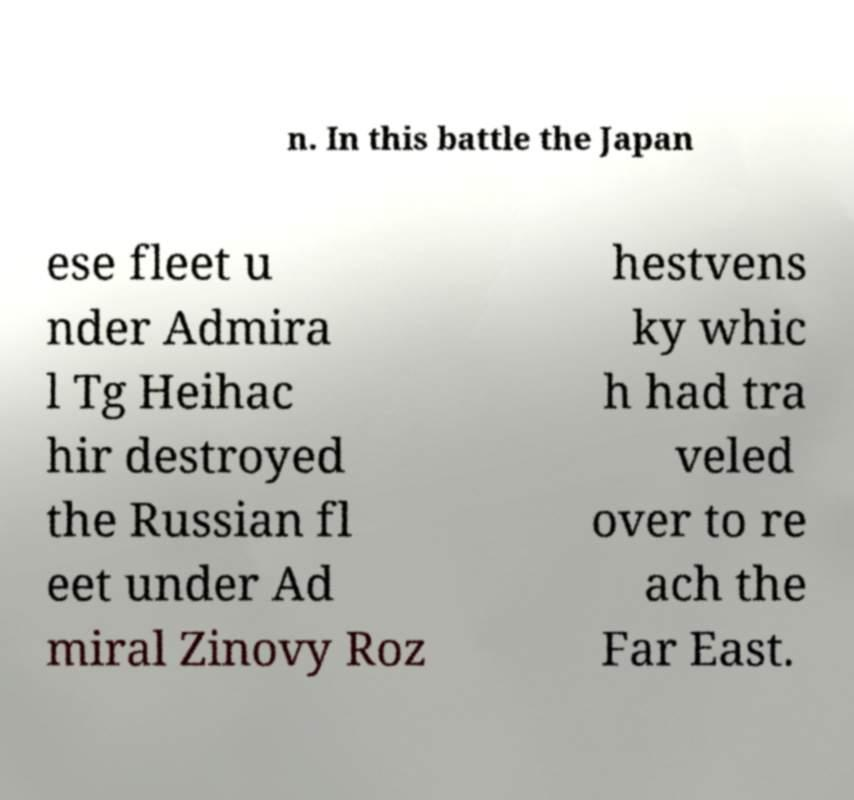Please identify and transcribe the text found in this image. n. In this battle the Japan ese fleet u nder Admira l Tg Heihac hir destroyed the Russian fl eet under Ad miral Zinovy Roz hestvens ky whic h had tra veled over to re ach the Far East. 